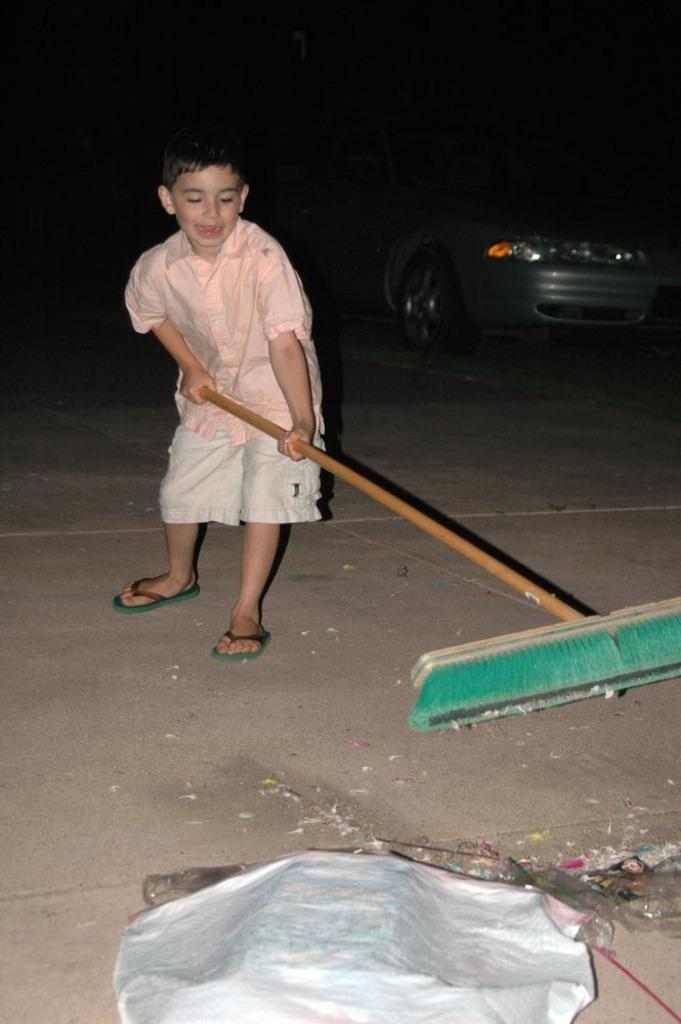What is the boy in the image doing? The boy is standing in the image and holding a broom. What is on the surface in the image? There is cloth and trash on the surface in the image. What can be seen in the background of the image? The background of the image is dark, and there is a car visible. What type of linen is the woman using to kick the ball in the image? There is no woman or ball present in the image; it features a boy holding a broom and a surface with cloth and trash. 